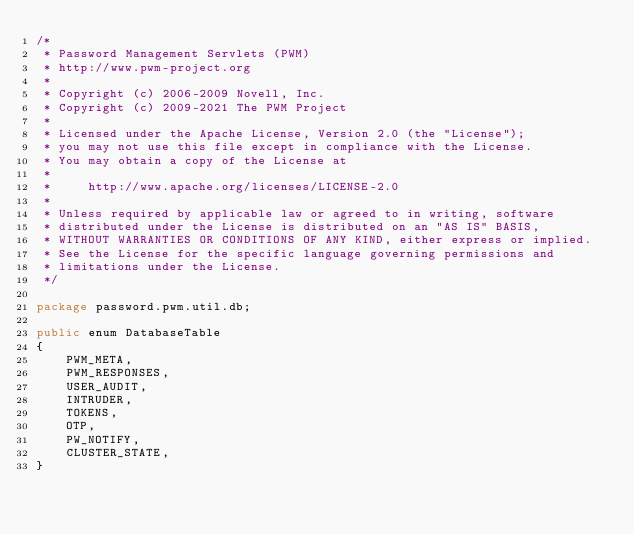Convert code to text. <code><loc_0><loc_0><loc_500><loc_500><_Java_>/*
 * Password Management Servlets (PWM)
 * http://www.pwm-project.org
 *
 * Copyright (c) 2006-2009 Novell, Inc.
 * Copyright (c) 2009-2021 The PWM Project
 *
 * Licensed under the Apache License, Version 2.0 (the "License");
 * you may not use this file except in compliance with the License.
 * You may obtain a copy of the License at
 *
 *     http://www.apache.org/licenses/LICENSE-2.0
 *
 * Unless required by applicable law or agreed to in writing, software
 * distributed under the License is distributed on an "AS IS" BASIS,
 * WITHOUT WARRANTIES OR CONDITIONS OF ANY KIND, either express or implied.
 * See the License for the specific language governing permissions and
 * limitations under the License.
 */

package password.pwm.util.db;

public enum DatabaseTable
{
    PWM_META,
    PWM_RESPONSES,
    USER_AUDIT,
    INTRUDER,
    TOKENS,
    OTP,
    PW_NOTIFY,
    CLUSTER_STATE,
}
</code> 